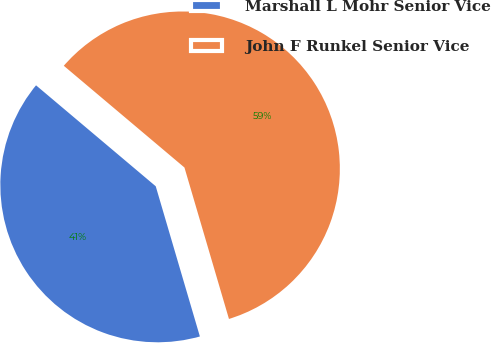Convert chart. <chart><loc_0><loc_0><loc_500><loc_500><pie_chart><fcel>Marshall L Mohr Senior Vice<fcel>John F Runkel Senior Vice<nl><fcel>40.7%<fcel>59.3%<nl></chart> 